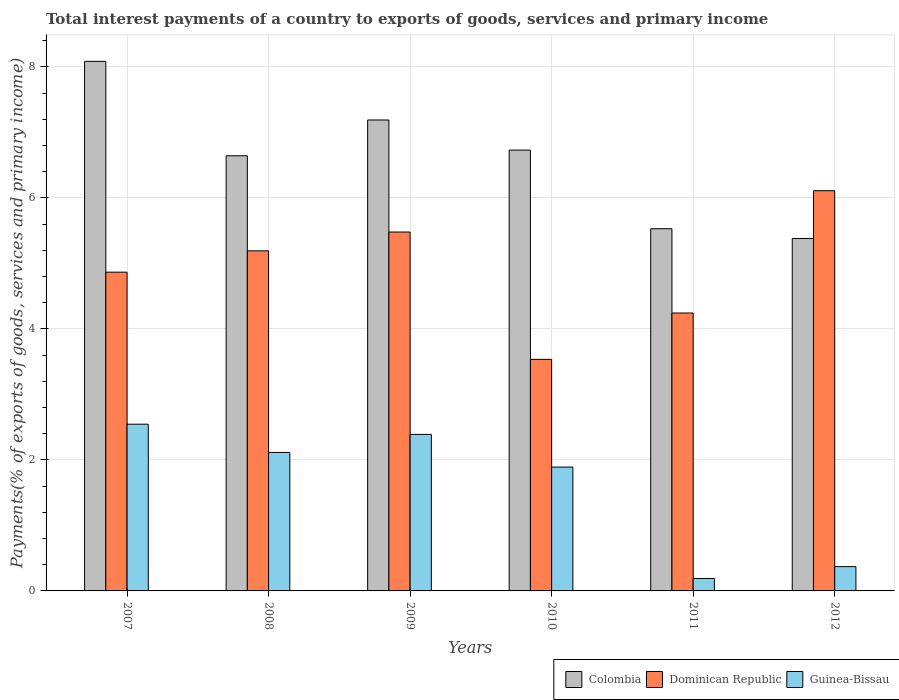How many different coloured bars are there?
Provide a succinct answer. 3. Are the number of bars per tick equal to the number of legend labels?
Your answer should be very brief. Yes. What is the total interest payments in Guinea-Bissau in 2012?
Make the answer very short. 0.37. Across all years, what is the maximum total interest payments in Dominican Republic?
Your answer should be compact. 6.11. Across all years, what is the minimum total interest payments in Guinea-Bissau?
Keep it short and to the point. 0.19. What is the total total interest payments in Colombia in the graph?
Your answer should be very brief. 39.56. What is the difference between the total interest payments in Guinea-Bissau in 2010 and that in 2011?
Your response must be concise. 1.7. What is the difference between the total interest payments in Dominican Republic in 2011 and the total interest payments in Colombia in 2008?
Give a very brief answer. -2.4. What is the average total interest payments in Colombia per year?
Provide a succinct answer. 6.59. In the year 2007, what is the difference between the total interest payments in Guinea-Bissau and total interest payments in Dominican Republic?
Ensure brevity in your answer.  -2.32. In how many years, is the total interest payments in Dominican Republic greater than 2.8 %?
Keep it short and to the point. 6. What is the ratio of the total interest payments in Dominican Republic in 2010 to that in 2012?
Your answer should be compact. 0.58. Is the difference between the total interest payments in Guinea-Bissau in 2009 and 2010 greater than the difference between the total interest payments in Dominican Republic in 2009 and 2010?
Offer a terse response. No. What is the difference between the highest and the second highest total interest payments in Colombia?
Keep it short and to the point. 0.9. What is the difference between the highest and the lowest total interest payments in Guinea-Bissau?
Provide a short and direct response. 2.36. In how many years, is the total interest payments in Dominican Republic greater than the average total interest payments in Dominican Republic taken over all years?
Make the answer very short. 3. Is the sum of the total interest payments in Guinea-Bissau in 2007 and 2008 greater than the maximum total interest payments in Dominican Republic across all years?
Offer a very short reply. No. What does the 3rd bar from the left in 2010 represents?
Your answer should be very brief. Guinea-Bissau. What does the 3rd bar from the right in 2008 represents?
Ensure brevity in your answer.  Colombia. Is it the case that in every year, the sum of the total interest payments in Dominican Republic and total interest payments in Guinea-Bissau is greater than the total interest payments in Colombia?
Make the answer very short. No. Does the graph contain any zero values?
Provide a short and direct response. No. Does the graph contain grids?
Provide a short and direct response. Yes. Where does the legend appear in the graph?
Keep it short and to the point. Bottom right. How are the legend labels stacked?
Provide a succinct answer. Horizontal. What is the title of the graph?
Your answer should be compact. Total interest payments of a country to exports of goods, services and primary income. Does "Latvia" appear as one of the legend labels in the graph?
Ensure brevity in your answer.  No. What is the label or title of the X-axis?
Your answer should be very brief. Years. What is the label or title of the Y-axis?
Give a very brief answer. Payments(% of exports of goods, services and primary income). What is the Payments(% of exports of goods, services and primary income) in Colombia in 2007?
Keep it short and to the point. 8.09. What is the Payments(% of exports of goods, services and primary income) in Dominican Republic in 2007?
Offer a very short reply. 4.87. What is the Payments(% of exports of goods, services and primary income) of Guinea-Bissau in 2007?
Ensure brevity in your answer.  2.55. What is the Payments(% of exports of goods, services and primary income) in Colombia in 2008?
Your answer should be compact. 6.64. What is the Payments(% of exports of goods, services and primary income) in Dominican Republic in 2008?
Make the answer very short. 5.19. What is the Payments(% of exports of goods, services and primary income) in Guinea-Bissau in 2008?
Provide a short and direct response. 2.11. What is the Payments(% of exports of goods, services and primary income) of Colombia in 2009?
Keep it short and to the point. 7.19. What is the Payments(% of exports of goods, services and primary income) in Dominican Republic in 2009?
Ensure brevity in your answer.  5.48. What is the Payments(% of exports of goods, services and primary income) in Guinea-Bissau in 2009?
Your response must be concise. 2.39. What is the Payments(% of exports of goods, services and primary income) of Colombia in 2010?
Give a very brief answer. 6.73. What is the Payments(% of exports of goods, services and primary income) of Dominican Republic in 2010?
Keep it short and to the point. 3.54. What is the Payments(% of exports of goods, services and primary income) in Guinea-Bissau in 2010?
Make the answer very short. 1.89. What is the Payments(% of exports of goods, services and primary income) of Colombia in 2011?
Offer a terse response. 5.53. What is the Payments(% of exports of goods, services and primary income) in Dominican Republic in 2011?
Keep it short and to the point. 4.24. What is the Payments(% of exports of goods, services and primary income) in Guinea-Bissau in 2011?
Keep it short and to the point. 0.19. What is the Payments(% of exports of goods, services and primary income) in Colombia in 2012?
Give a very brief answer. 5.38. What is the Payments(% of exports of goods, services and primary income) in Dominican Republic in 2012?
Your answer should be very brief. 6.11. What is the Payments(% of exports of goods, services and primary income) of Guinea-Bissau in 2012?
Keep it short and to the point. 0.37. Across all years, what is the maximum Payments(% of exports of goods, services and primary income) in Colombia?
Your response must be concise. 8.09. Across all years, what is the maximum Payments(% of exports of goods, services and primary income) in Dominican Republic?
Make the answer very short. 6.11. Across all years, what is the maximum Payments(% of exports of goods, services and primary income) of Guinea-Bissau?
Keep it short and to the point. 2.55. Across all years, what is the minimum Payments(% of exports of goods, services and primary income) in Colombia?
Your response must be concise. 5.38. Across all years, what is the minimum Payments(% of exports of goods, services and primary income) of Dominican Republic?
Give a very brief answer. 3.54. Across all years, what is the minimum Payments(% of exports of goods, services and primary income) of Guinea-Bissau?
Ensure brevity in your answer.  0.19. What is the total Payments(% of exports of goods, services and primary income) of Colombia in the graph?
Your answer should be very brief. 39.56. What is the total Payments(% of exports of goods, services and primary income) of Dominican Republic in the graph?
Your answer should be very brief. 29.43. What is the total Payments(% of exports of goods, services and primary income) of Guinea-Bissau in the graph?
Your answer should be very brief. 9.5. What is the difference between the Payments(% of exports of goods, services and primary income) in Colombia in 2007 and that in 2008?
Keep it short and to the point. 1.44. What is the difference between the Payments(% of exports of goods, services and primary income) in Dominican Republic in 2007 and that in 2008?
Provide a succinct answer. -0.33. What is the difference between the Payments(% of exports of goods, services and primary income) in Guinea-Bissau in 2007 and that in 2008?
Provide a short and direct response. 0.43. What is the difference between the Payments(% of exports of goods, services and primary income) in Colombia in 2007 and that in 2009?
Ensure brevity in your answer.  0.9. What is the difference between the Payments(% of exports of goods, services and primary income) in Dominican Republic in 2007 and that in 2009?
Make the answer very short. -0.61. What is the difference between the Payments(% of exports of goods, services and primary income) in Guinea-Bissau in 2007 and that in 2009?
Your answer should be compact. 0.16. What is the difference between the Payments(% of exports of goods, services and primary income) in Colombia in 2007 and that in 2010?
Make the answer very short. 1.35. What is the difference between the Payments(% of exports of goods, services and primary income) in Dominican Republic in 2007 and that in 2010?
Give a very brief answer. 1.33. What is the difference between the Payments(% of exports of goods, services and primary income) of Guinea-Bissau in 2007 and that in 2010?
Keep it short and to the point. 0.65. What is the difference between the Payments(% of exports of goods, services and primary income) of Colombia in 2007 and that in 2011?
Your response must be concise. 2.56. What is the difference between the Payments(% of exports of goods, services and primary income) in Dominican Republic in 2007 and that in 2011?
Your answer should be very brief. 0.62. What is the difference between the Payments(% of exports of goods, services and primary income) of Guinea-Bissau in 2007 and that in 2011?
Your response must be concise. 2.36. What is the difference between the Payments(% of exports of goods, services and primary income) of Colombia in 2007 and that in 2012?
Offer a very short reply. 2.7. What is the difference between the Payments(% of exports of goods, services and primary income) in Dominican Republic in 2007 and that in 2012?
Your answer should be compact. -1.24. What is the difference between the Payments(% of exports of goods, services and primary income) in Guinea-Bissau in 2007 and that in 2012?
Your response must be concise. 2.17. What is the difference between the Payments(% of exports of goods, services and primary income) of Colombia in 2008 and that in 2009?
Offer a terse response. -0.55. What is the difference between the Payments(% of exports of goods, services and primary income) of Dominican Republic in 2008 and that in 2009?
Offer a terse response. -0.29. What is the difference between the Payments(% of exports of goods, services and primary income) of Guinea-Bissau in 2008 and that in 2009?
Your answer should be compact. -0.28. What is the difference between the Payments(% of exports of goods, services and primary income) in Colombia in 2008 and that in 2010?
Make the answer very short. -0.09. What is the difference between the Payments(% of exports of goods, services and primary income) in Dominican Republic in 2008 and that in 2010?
Your response must be concise. 1.66. What is the difference between the Payments(% of exports of goods, services and primary income) in Guinea-Bissau in 2008 and that in 2010?
Your answer should be very brief. 0.22. What is the difference between the Payments(% of exports of goods, services and primary income) in Colombia in 2008 and that in 2011?
Provide a short and direct response. 1.11. What is the difference between the Payments(% of exports of goods, services and primary income) in Dominican Republic in 2008 and that in 2011?
Keep it short and to the point. 0.95. What is the difference between the Payments(% of exports of goods, services and primary income) of Guinea-Bissau in 2008 and that in 2011?
Offer a very short reply. 1.92. What is the difference between the Payments(% of exports of goods, services and primary income) of Colombia in 2008 and that in 2012?
Offer a terse response. 1.26. What is the difference between the Payments(% of exports of goods, services and primary income) of Dominican Republic in 2008 and that in 2012?
Keep it short and to the point. -0.92. What is the difference between the Payments(% of exports of goods, services and primary income) of Guinea-Bissau in 2008 and that in 2012?
Your response must be concise. 1.74. What is the difference between the Payments(% of exports of goods, services and primary income) in Colombia in 2009 and that in 2010?
Provide a short and direct response. 0.46. What is the difference between the Payments(% of exports of goods, services and primary income) in Dominican Republic in 2009 and that in 2010?
Offer a very short reply. 1.94. What is the difference between the Payments(% of exports of goods, services and primary income) of Guinea-Bissau in 2009 and that in 2010?
Provide a succinct answer. 0.5. What is the difference between the Payments(% of exports of goods, services and primary income) in Colombia in 2009 and that in 2011?
Give a very brief answer. 1.66. What is the difference between the Payments(% of exports of goods, services and primary income) of Dominican Republic in 2009 and that in 2011?
Your answer should be compact. 1.24. What is the difference between the Payments(% of exports of goods, services and primary income) of Guinea-Bissau in 2009 and that in 2011?
Give a very brief answer. 2.2. What is the difference between the Payments(% of exports of goods, services and primary income) of Colombia in 2009 and that in 2012?
Keep it short and to the point. 1.81. What is the difference between the Payments(% of exports of goods, services and primary income) of Dominican Republic in 2009 and that in 2012?
Give a very brief answer. -0.63. What is the difference between the Payments(% of exports of goods, services and primary income) of Guinea-Bissau in 2009 and that in 2012?
Provide a succinct answer. 2.02. What is the difference between the Payments(% of exports of goods, services and primary income) in Colombia in 2010 and that in 2011?
Make the answer very short. 1.2. What is the difference between the Payments(% of exports of goods, services and primary income) in Dominican Republic in 2010 and that in 2011?
Your response must be concise. -0.71. What is the difference between the Payments(% of exports of goods, services and primary income) of Guinea-Bissau in 2010 and that in 2011?
Provide a succinct answer. 1.7. What is the difference between the Payments(% of exports of goods, services and primary income) of Colombia in 2010 and that in 2012?
Provide a succinct answer. 1.35. What is the difference between the Payments(% of exports of goods, services and primary income) of Dominican Republic in 2010 and that in 2012?
Your response must be concise. -2.58. What is the difference between the Payments(% of exports of goods, services and primary income) of Guinea-Bissau in 2010 and that in 2012?
Offer a very short reply. 1.52. What is the difference between the Payments(% of exports of goods, services and primary income) in Colombia in 2011 and that in 2012?
Provide a succinct answer. 0.15. What is the difference between the Payments(% of exports of goods, services and primary income) of Dominican Republic in 2011 and that in 2012?
Provide a succinct answer. -1.87. What is the difference between the Payments(% of exports of goods, services and primary income) of Guinea-Bissau in 2011 and that in 2012?
Your response must be concise. -0.18. What is the difference between the Payments(% of exports of goods, services and primary income) in Colombia in 2007 and the Payments(% of exports of goods, services and primary income) in Dominican Republic in 2008?
Provide a short and direct response. 2.89. What is the difference between the Payments(% of exports of goods, services and primary income) of Colombia in 2007 and the Payments(% of exports of goods, services and primary income) of Guinea-Bissau in 2008?
Make the answer very short. 5.97. What is the difference between the Payments(% of exports of goods, services and primary income) of Dominican Republic in 2007 and the Payments(% of exports of goods, services and primary income) of Guinea-Bissau in 2008?
Your answer should be compact. 2.75. What is the difference between the Payments(% of exports of goods, services and primary income) in Colombia in 2007 and the Payments(% of exports of goods, services and primary income) in Dominican Republic in 2009?
Offer a terse response. 2.61. What is the difference between the Payments(% of exports of goods, services and primary income) of Colombia in 2007 and the Payments(% of exports of goods, services and primary income) of Guinea-Bissau in 2009?
Provide a succinct answer. 5.7. What is the difference between the Payments(% of exports of goods, services and primary income) in Dominican Republic in 2007 and the Payments(% of exports of goods, services and primary income) in Guinea-Bissau in 2009?
Provide a short and direct response. 2.48. What is the difference between the Payments(% of exports of goods, services and primary income) in Colombia in 2007 and the Payments(% of exports of goods, services and primary income) in Dominican Republic in 2010?
Your response must be concise. 4.55. What is the difference between the Payments(% of exports of goods, services and primary income) in Colombia in 2007 and the Payments(% of exports of goods, services and primary income) in Guinea-Bissau in 2010?
Offer a terse response. 6.19. What is the difference between the Payments(% of exports of goods, services and primary income) of Dominican Republic in 2007 and the Payments(% of exports of goods, services and primary income) of Guinea-Bissau in 2010?
Offer a very short reply. 2.98. What is the difference between the Payments(% of exports of goods, services and primary income) of Colombia in 2007 and the Payments(% of exports of goods, services and primary income) of Dominican Republic in 2011?
Provide a succinct answer. 3.84. What is the difference between the Payments(% of exports of goods, services and primary income) in Colombia in 2007 and the Payments(% of exports of goods, services and primary income) in Guinea-Bissau in 2011?
Your answer should be very brief. 7.9. What is the difference between the Payments(% of exports of goods, services and primary income) in Dominican Republic in 2007 and the Payments(% of exports of goods, services and primary income) in Guinea-Bissau in 2011?
Offer a very short reply. 4.68. What is the difference between the Payments(% of exports of goods, services and primary income) in Colombia in 2007 and the Payments(% of exports of goods, services and primary income) in Dominican Republic in 2012?
Your response must be concise. 1.97. What is the difference between the Payments(% of exports of goods, services and primary income) in Colombia in 2007 and the Payments(% of exports of goods, services and primary income) in Guinea-Bissau in 2012?
Provide a short and direct response. 7.71. What is the difference between the Payments(% of exports of goods, services and primary income) of Dominican Republic in 2007 and the Payments(% of exports of goods, services and primary income) of Guinea-Bissau in 2012?
Your response must be concise. 4.5. What is the difference between the Payments(% of exports of goods, services and primary income) of Colombia in 2008 and the Payments(% of exports of goods, services and primary income) of Dominican Republic in 2009?
Offer a very short reply. 1.16. What is the difference between the Payments(% of exports of goods, services and primary income) in Colombia in 2008 and the Payments(% of exports of goods, services and primary income) in Guinea-Bissau in 2009?
Make the answer very short. 4.25. What is the difference between the Payments(% of exports of goods, services and primary income) in Dominican Republic in 2008 and the Payments(% of exports of goods, services and primary income) in Guinea-Bissau in 2009?
Your answer should be compact. 2.8. What is the difference between the Payments(% of exports of goods, services and primary income) of Colombia in 2008 and the Payments(% of exports of goods, services and primary income) of Dominican Republic in 2010?
Your answer should be compact. 3.11. What is the difference between the Payments(% of exports of goods, services and primary income) in Colombia in 2008 and the Payments(% of exports of goods, services and primary income) in Guinea-Bissau in 2010?
Your answer should be compact. 4.75. What is the difference between the Payments(% of exports of goods, services and primary income) in Dominican Republic in 2008 and the Payments(% of exports of goods, services and primary income) in Guinea-Bissau in 2010?
Make the answer very short. 3.3. What is the difference between the Payments(% of exports of goods, services and primary income) in Colombia in 2008 and the Payments(% of exports of goods, services and primary income) in Dominican Republic in 2011?
Keep it short and to the point. 2.4. What is the difference between the Payments(% of exports of goods, services and primary income) of Colombia in 2008 and the Payments(% of exports of goods, services and primary income) of Guinea-Bissau in 2011?
Offer a terse response. 6.45. What is the difference between the Payments(% of exports of goods, services and primary income) in Dominican Republic in 2008 and the Payments(% of exports of goods, services and primary income) in Guinea-Bissau in 2011?
Keep it short and to the point. 5. What is the difference between the Payments(% of exports of goods, services and primary income) of Colombia in 2008 and the Payments(% of exports of goods, services and primary income) of Dominican Republic in 2012?
Offer a terse response. 0.53. What is the difference between the Payments(% of exports of goods, services and primary income) of Colombia in 2008 and the Payments(% of exports of goods, services and primary income) of Guinea-Bissau in 2012?
Your answer should be very brief. 6.27. What is the difference between the Payments(% of exports of goods, services and primary income) in Dominican Republic in 2008 and the Payments(% of exports of goods, services and primary income) in Guinea-Bissau in 2012?
Make the answer very short. 4.82. What is the difference between the Payments(% of exports of goods, services and primary income) of Colombia in 2009 and the Payments(% of exports of goods, services and primary income) of Dominican Republic in 2010?
Your answer should be compact. 3.65. What is the difference between the Payments(% of exports of goods, services and primary income) in Colombia in 2009 and the Payments(% of exports of goods, services and primary income) in Guinea-Bissau in 2010?
Provide a short and direct response. 5.3. What is the difference between the Payments(% of exports of goods, services and primary income) of Dominican Republic in 2009 and the Payments(% of exports of goods, services and primary income) of Guinea-Bissau in 2010?
Make the answer very short. 3.59. What is the difference between the Payments(% of exports of goods, services and primary income) in Colombia in 2009 and the Payments(% of exports of goods, services and primary income) in Dominican Republic in 2011?
Your answer should be compact. 2.95. What is the difference between the Payments(% of exports of goods, services and primary income) of Colombia in 2009 and the Payments(% of exports of goods, services and primary income) of Guinea-Bissau in 2011?
Your answer should be very brief. 7. What is the difference between the Payments(% of exports of goods, services and primary income) of Dominican Republic in 2009 and the Payments(% of exports of goods, services and primary income) of Guinea-Bissau in 2011?
Offer a very short reply. 5.29. What is the difference between the Payments(% of exports of goods, services and primary income) of Colombia in 2009 and the Payments(% of exports of goods, services and primary income) of Dominican Republic in 2012?
Your answer should be compact. 1.08. What is the difference between the Payments(% of exports of goods, services and primary income) in Colombia in 2009 and the Payments(% of exports of goods, services and primary income) in Guinea-Bissau in 2012?
Provide a short and direct response. 6.82. What is the difference between the Payments(% of exports of goods, services and primary income) of Dominican Republic in 2009 and the Payments(% of exports of goods, services and primary income) of Guinea-Bissau in 2012?
Ensure brevity in your answer.  5.11. What is the difference between the Payments(% of exports of goods, services and primary income) of Colombia in 2010 and the Payments(% of exports of goods, services and primary income) of Dominican Republic in 2011?
Make the answer very short. 2.49. What is the difference between the Payments(% of exports of goods, services and primary income) of Colombia in 2010 and the Payments(% of exports of goods, services and primary income) of Guinea-Bissau in 2011?
Give a very brief answer. 6.54. What is the difference between the Payments(% of exports of goods, services and primary income) of Dominican Republic in 2010 and the Payments(% of exports of goods, services and primary income) of Guinea-Bissau in 2011?
Give a very brief answer. 3.35. What is the difference between the Payments(% of exports of goods, services and primary income) of Colombia in 2010 and the Payments(% of exports of goods, services and primary income) of Dominican Republic in 2012?
Offer a terse response. 0.62. What is the difference between the Payments(% of exports of goods, services and primary income) in Colombia in 2010 and the Payments(% of exports of goods, services and primary income) in Guinea-Bissau in 2012?
Provide a short and direct response. 6.36. What is the difference between the Payments(% of exports of goods, services and primary income) in Dominican Republic in 2010 and the Payments(% of exports of goods, services and primary income) in Guinea-Bissau in 2012?
Provide a succinct answer. 3.16. What is the difference between the Payments(% of exports of goods, services and primary income) in Colombia in 2011 and the Payments(% of exports of goods, services and primary income) in Dominican Republic in 2012?
Make the answer very short. -0.58. What is the difference between the Payments(% of exports of goods, services and primary income) of Colombia in 2011 and the Payments(% of exports of goods, services and primary income) of Guinea-Bissau in 2012?
Your response must be concise. 5.16. What is the difference between the Payments(% of exports of goods, services and primary income) in Dominican Republic in 2011 and the Payments(% of exports of goods, services and primary income) in Guinea-Bissau in 2012?
Provide a short and direct response. 3.87. What is the average Payments(% of exports of goods, services and primary income) of Colombia per year?
Your answer should be very brief. 6.59. What is the average Payments(% of exports of goods, services and primary income) of Dominican Republic per year?
Ensure brevity in your answer.  4.9. What is the average Payments(% of exports of goods, services and primary income) in Guinea-Bissau per year?
Provide a succinct answer. 1.58. In the year 2007, what is the difference between the Payments(% of exports of goods, services and primary income) of Colombia and Payments(% of exports of goods, services and primary income) of Dominican Republic?
Provide a short and direct response. 3.22. In the year 2007, what is the difference between the Payments(% of exports of goods, services and primary income) of Colombia and Payments(% of exports of goods, services and primary income) of Guinea-Bissau?
Your response must be concise. 5.54. In the year 2007, what is the difference between the Payments(% of exports of goods, services and primary income) of Dominican Republic and Payments(% of exports of goods, services and primary income) of Guinea-Bissau?
Ensure brevity in your answer.  2.32. In the year 2008, what is the difference between the Payments(% of exports of goods, services and primary income) of Colombia and Payments(% of exports of goods, services and primary income) of Dominican Republic?
Your response must be concise. 1.45. In the year 2008, what is the difference between the Payments(% of exports of goods, services and primary income) of Colombia and Payments(% of exports of goods, services and primary income) of Guinea-Bissau?
Your answer should be very brief. 4.53. In the year 2008, what is the difference between the Payments(% of exports of goods, services and primary income) in Dominican Republic and Payments(% of exports of goods, services and primary income) in Guinea-Bissau?
Your answer should be very brief. 3.08. In the year 2009, what is the difference between the Payments(% of exports of goods, services and primary income) in Colombia and Payments(% of exports of goods, services and primary income) in Dominican Republic?
Offer a terse response. 1.71. In the year 2009, what is the difference between the Payments(% of exports of goods, services and primary income) in Colombia and Payments(% of exports of goods, services and primary income) in Guinea-Bissau?
Ensure brevity in your answer.  4.8. In the year 2009, what is the difference between the Payments(% of exports of goods, services and primary income) of Dominican Republic and Payments(% of exports of goods, services and primary income) of Guinea-Bissau?
Your answer should be compact. 3.09. In the year 2010, what is the difference between the Payments(% of exports of goods, services and primary income) of Colombia and Payments(% of exports of goods, services and primary income) of Dominican Republic?
Provide a short and direct response. 3.2. In the year 2010, what is the difference between the Payments(% of exports of goods, services and primary income) in Colombia and Payments(% of exports of goods, services and primary income) in Guinea-Bissau?
Your response must be concise. 4.84. In the year 2010, what is the difference between the Payments(% of exports of goods, services and primary income) in Dominican Republic and Payments(% of exports of goods, services and primary income) in Guinea-Bissau?
Provide a short and direct response. 1.64. In the year 2011, what is the difference between the Payments(% of exports of goods, services and primary income) of Colombia and Payments(% of exports of goods, services and primary income) of Dominican Republic?
Offer a very short reply. 1.29. In the year 2011, what is the difference between the Payments(% of exports of goods, services and primary income) in Colombia and Payments(% of exports of goods, services and primary income) in Guinea-Bissau?
Keep it short and to the point. 5.34. In the year 2011, what is the difference between the Payments(% of exports of goods, services and primary income) in Dominican Republic and Payments(% of exports of goods, services and primary income) in Guinea-Bissau?
Ensure brevity in your answer.  4.05. In the year 2012, what is the difference between the Payments(% of exports of goods, services and primary income) of Colombia and Payments(% of exports of goods, services and primary income) of Dominican Republic?
Provide a short and direct response. -0.73. In the year 2012, what is the difference between the Payments(% of exports of goods, services and primary income) in Colombia and Payments(% of exports of goods, services and primary income) in Guinea-Bissau?
Offer a terse response. 5.01. In the year 2012, what is the difference between the Payments(% of exports of goods, services and primary income) of Dominican Republic and Payments(% of exports of goods, services and primary income) of Guinea-Bissau?
Ensure brevity in your answer.  5.74. What is the ratio of the Payments(% of exports of goods, services and primary income) of Colombia in 2007 to that in 2008?
Provide a succinct answer. 1.22. What is the ratio of the Payments(% of exports of goods, services and primary income) of Dominican Republic in 2007 to that in 2008?
Ensure brevity in your answer.  0.94. What is the ratio of the Payments(% of exports of goods, services and primary income) in Guinea-Bissau in 2007 to that in 2008?
Provide a succinct answer. 1.2. What is the ratio of the Payments(% of exports of goods, services and primary income) of Colombia in 2007 to that in 2009?
Offer a terse response. 1.12. What is the ratio of the Payments(% of exports of goods, services and primary income) of Dominican Republic in 2007 to that in 2009?
Your response must be concise. 0.89. What is the ratio of the Payments(% of exports of goods, services and primary income) of Guinea-Bissau in 2007 to that in 2009?
Offer a very short reply. 1.07. What is the ratio of the Payments(% of exports of goods, services and primary income) of Colombia in 2007 to that in 2010?
Your answer should be compact. 1.2. What is the ratio of the Payments(% of exports of goods, services and primary income) in Dominican Republic in 2007 to that in 2010?
Ensure brevity in your answer.  1.38. What is the ratio of the Payments(% of exports of goods, services and primary income) of Guinea-Bissau in 2007 to that in 2010?
Your answer should be very brief. 1.35. What is the ratio of the Payments(% of exports of goods, services and primary income) of Colombia in 2007 to that in 2011?
Provide a succinct answer. 1.46. What is the ratio of the Payments(% of exports of goods, services and primary income) of Dominican Republic in 2007 to that in 2011?
Your answer should be compact. 1.15. What is the ratio of the Payments(% of exports of goods, services and primary income) in Guinea-Bissau in 2007 to that in 2011?
Keep it short and to the point. 13.42. What is the ratio of the Payments(% of exports of goods, services and primary income) of Colombia in 2007 to that in 2012?
Your answer should be compact. 1.5. What is the ratio of the Payments(% of exports of goods, services and primary income) of Dominican Republic in 2007 to that in 2012?
Offer a terse response. 0.8. What is the ratio of the Payments(% of exports of goods, services and primary income) in Guinea-Bissau in 2007 to that in 2012?
Your response must be concise. 6.86. What is the ratio of the Payments(% of exports of goods, services and primary income) in Colombia in 2008 to that in 2009?
Offer a very short reply. 0.92. What is the ratio of the Payments(% of exports of goods, services and primary income) of Dominican Republic in 2008 to that in 2009?
Make the answer very short. 0.95. What is the ratio of the Payments(% of exports of goods, services and primary income) of Guinea-Bissau in 2008 to that in 2009?
Ensure brevity in your answer.  0.88. What is the ratio of the Payments(% of exports of goods, services and primary income) in Colombia in 2008 to that in 2010?
Ensure brevity in your answer.  0.99. What is the ratio of the Payments(% of exports of goods, services and primary income) in Dominican Republic in 2008 to that in 2010?
Ensure brevity in your answer.  1.47. What is the ratio of the Payments(% of exports of goods, services and primary income) in Guinea-Bissau in 2008 to that in 2010?
Keep it short and to the point. 1.12. What is the ratio of the Payments(% of exports of goods, services and primary income) of Colombia in 2008 to that in 2011?
Keep it short and to the point. 1.2. What is the ratio of the Payments(% of exports of goods, services and primary income) in Dominican Republic in 2008 to that in 2011?
Provide a succinct answer. 1.22. What is the ratio of the Payments(% of exports of goods, services and primary income) in Guinea-Bissau in 2008 to that in 2011?
Keep it short and to the point. 11.15. What is the ratio of the Payments(% of exports of goods, services and primary income) in Colombia in 2008 to that in 2012?
Your answer should be very brief. 1.23. What is the ratio of the Payments(% of exports of goods, services and primary income) in Dominican Republic in 2008 to that in 2012?
Ensure brevity in your answer.  0.85. What is the ratio of the Payments(% of exports of goods, services and primary income) in Guinea-Bissau in 2008 to that in 2012?
Provide a short and direct response. 5.7. What is the ratio of the Payments(% of exports of goods, services and primary income) in Colombia in 2009 to that in 2010?
Keep it short and to the point. 1.07. What is the ratio of the Payments(% of exports of goods, services and primary income) of Dominican Republic in 2009 to that in 2010?
Offer a terse response. 1.55. What is the ratio of the Payments(% of exports of goods, services and primary income) in Guinea-Bissau in 2009 to that in 2010?
Ensure brevity in your answer.  1.26. What is the ratio of the Payments(% of exports of goods, services and primary income) in Colombia in 2009 to that in 2011?
Your response must be concise. 1.3. What is the ratio of the Payments(% of exports of goods, services and primary income) in Dominican Republic in 2009 to that in 2011?
Your answer should be very brief. 1.29. What is the ratio of the Payments(% of exports of goods, services and primary income) of Guinea-Bissau in 2009 to that in 2011?
Your answer should be compact. 12.6. What is the ratio of the Payments(% of exports of goods, services and primary income) in Colombia in 2009 to that in 2012?
Your answer should be very brief. 1.34. What is the ratio of the Payments(% of exports of goods, services and primary income) of Dominican Republic in 2009 to that in 2012?
Offer a terse response. 0.9. What is the ratio of the Payments(% of exports of goods, services and primary income) of Guinea-Bissau in 2009 to that in 2012?
Offer a very short reply. 6.44. What is the ratio of the Payments(% of exports of goods, services and primary income) in Colombia in 2010 to that in 2011?
Provide a succinct answer. 1.22. What is the ratio of the Payments(% of exports of goods, services and primary income) in Guinea-Bissau in 2010 to that in 2011?
Make the answer very short. 9.97. What is the ratio of the Payments(% of exports of goods, services and primary income) in Colombia in 2010 to that in 2012?
Your answer should be very brief. 1.25. What is the ratio of the Payments(% of exports of goods, services and primary income) in Dominican Republic in 2010 to that in 2012?
Keep it short and to the point. 0.58. What is the ratio of the Payments(% of exports of goods, services and primary income) in Guinea-Bissau in 2010 to that in 2012?
Provide a succinct answer. 5.09. What is the ratio of the Payments(% of exports of goods, services and primary income) of Colombia in 2011 to that in 2012?
Your response must be concise. 1.03. What is the ratio of the Payments(% of exports of goods, services and primary income) of Dominican Republic in 2011 to that in 2012?
Your response must be concise. 0.69. What is the ratio of the Payments(% of exports of goods, services and primary income) of Guinea-Bissau in 2011 to that in 2012?
Offer a very short reply. 0.51. What is the difference between the highest and the second highest Payments(% of exports of goods, services and primary income) of Colombia?
Your answer should be compact. 0.9. What is the difference between the highest and the second highest Payments(% of exports of goods, services and primary income) of Dominican Republic?
Ensure brevity in your answer.  0.63. What is the difference between the highest and the second highest Payments(% of exports of goods, services and primary income) of Guinea-Bissau?
Your response must be concise. 0.16. What is the difference between the highest and the lowest Payments(% of exports of goods, services and primary income) in Colombia?
Keep it short and to the point. 2.7. What is the difference between the highest and the lowest Payments(% of exports of goods, services and primary income) of Dominican Republic?
Provide a short and direct response. 2.58. What is the difference between the highest and the lowest Payments(% of exports of goods, services and primary income) in Guinea-Bissau?
Provide a succinct answer. 2.36. 